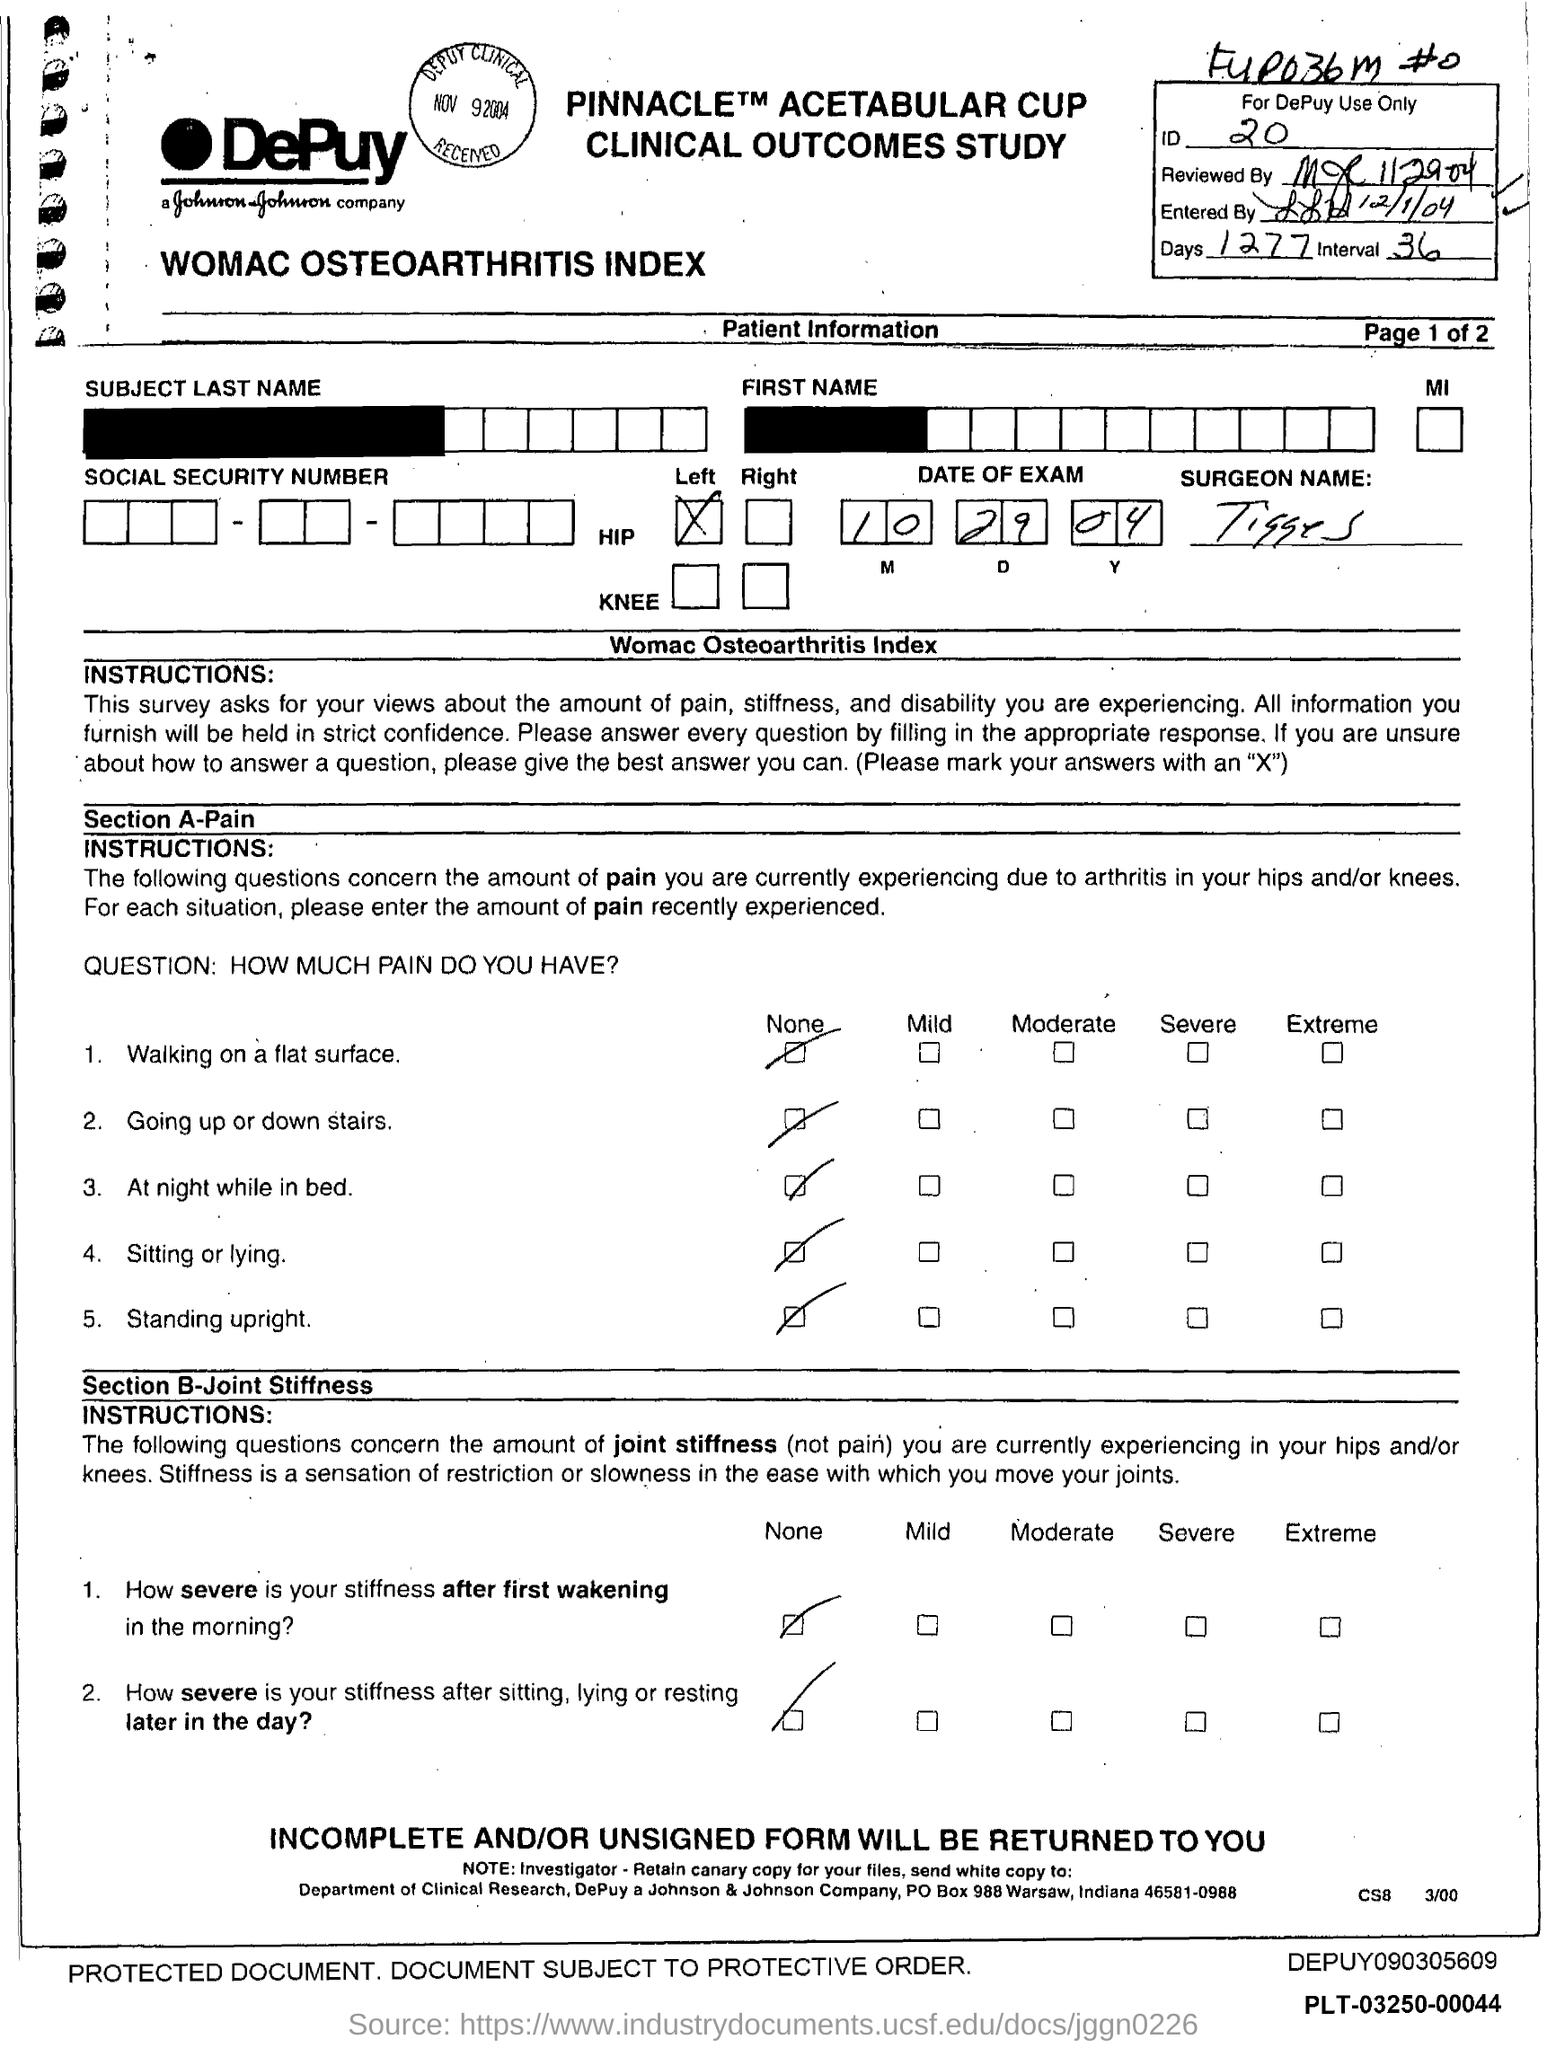Give some essential details in this illustration. The ID number is 20. The number of days is 1277. 